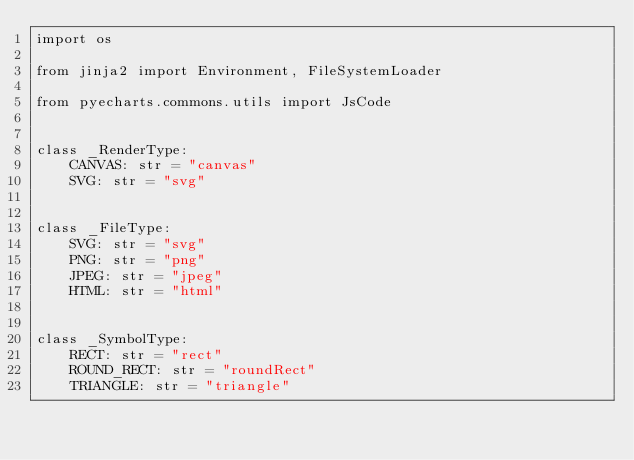Convert code to text. <code><loc_0><loc_0><loc_500><loc_500><_Python_>import os

from jinja2 import Environment, FileSystemLoader

from pyecharts.commons.utils import JsCode


class _RenderType:
    CANVAS: str = "canvas"
    SVG: str = "svg"


class _FileType:
    SVG: str = "svg"
    PNG: str = "png"
    JPEG: str = "jpeg"
    HTML: str = "html"


class _SymbolType:
    RECT: str = "rect"
    ROUND_RECT: str = "roundRect"
    TRIANGLE: str = "triangle"</code> 